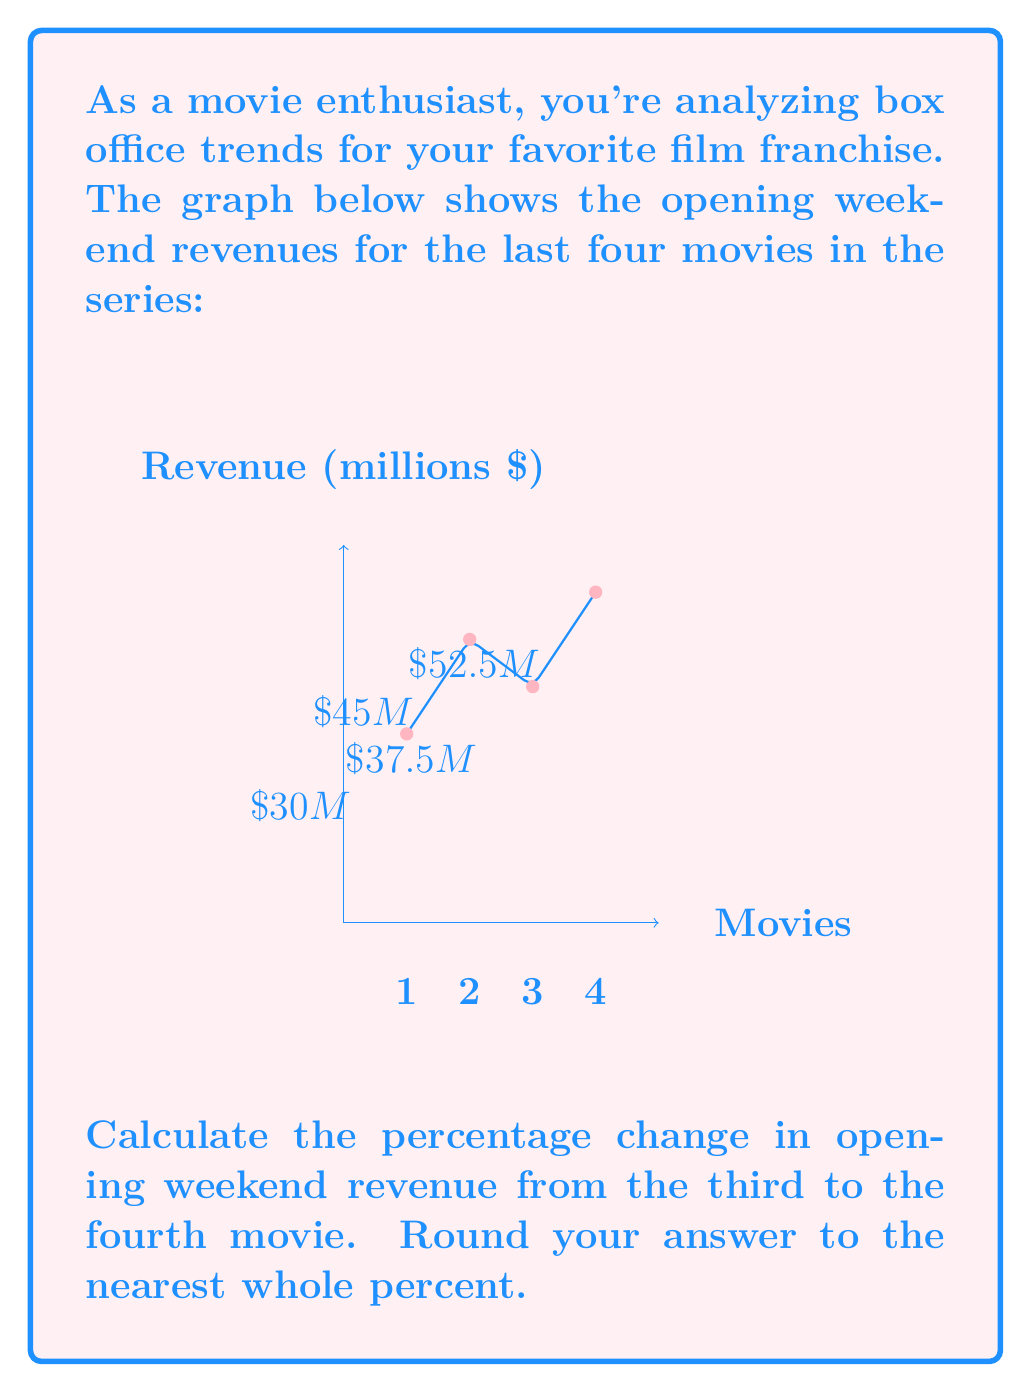Give your solution to this math problem. Let's approach this step-by-step:

1) First, we need to identify the revenue for the third and fourth movies:
   - Third movie (3): $\$37.5$ million
   - Fourth movie (4): $\$52.5$ million

2) To calculate the percentage change, we use the formula:

   $$ \text{Percentage Change} = \frac{\text{New Value} - \text{Original Value}}{\text{Original Value}} \times 100\% $$

3) Let's plug in our values:

   $$ \text{Percentage Change} = \frac{52.5 - 37.5}{37.5} \times 100\% $$

4) Simplify:
   $$ \text{Percentage Change} = \frac{15}{37.5} \times 100\% $$

5) Divide:
   $$ \text{Percentage Change} = 0.4 \times 100\% = 40\% $$

6) The question asks to round to the nearest whole percent, but 40% is already a whole number, so no further rounding is necessary.

Therefore, the opening weekend revenue increased by 40% from the third to the fourth movie.
Answer: 40% 